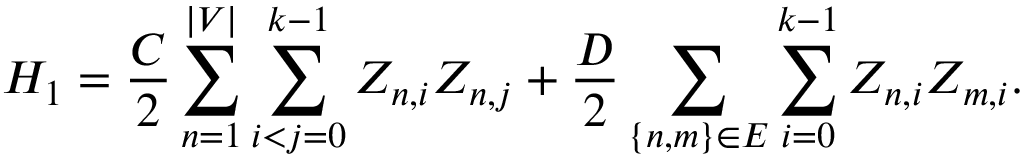<formula> <loc_0><loc_0><loc_500><loc_500>H _ { 1 } = \frac { C } { 2 } \sum _ { n = 1 } ^ { | V | } \sum _ { i < j = 0 } ^ { k - 1 } Z _ { n , i } Z _ { n , j } + \frac { D } { 2 } \sum _ { \{ n , m \} \in E } \sum _ { i = 0 } ^ { k - 1 } Z _ { n , i } Z _ { m , i } .</formula> 